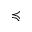Convert formula to latex. <formula><loc_0><loc_0><loc_500><loc_500>\prec c u r l y e q</formula> 